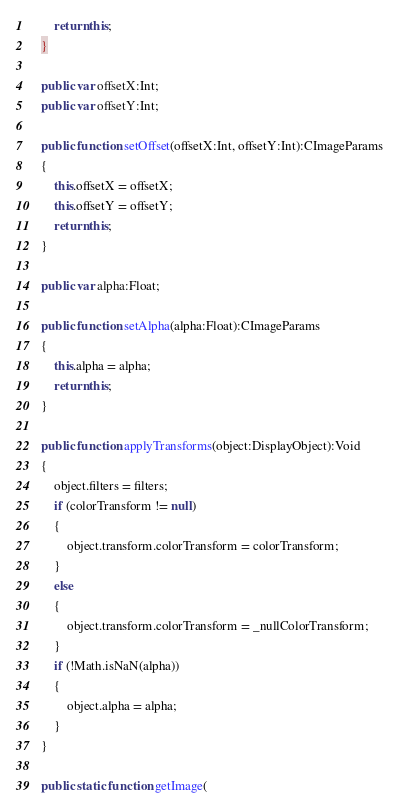<code> <loc_0><loc_0><loc_500><loc_500><_Haxe_>		return this;
	}
	
	public var offsetX:Int;
	public var offsetY:Int;
	
	public function setOffset(offsetX:Int, offsetY:Int):CImageParams
	{
		this.offsetX = offsetX;
		this.offsetY = offsetY;
		return this;
	}
	
	public var alpha:Float;
	
	public function setAlpha(alpha:Float):CImageParams
	{
		this.alpha = alpha;
		return this;
	}
	
	public function applyTransforms(object:DisplayObject):Void
	{
		object.filters = filters;
		if (colorTransform != null)
		{
			object.transform.colorTransform = colorTransform;
		}
		else
		{
			object.transform.colorTransform = _nullColorTransform;
		}
		if (!Math.isNaN(alpha))
		{
			object.alpha = alpha;
		}
	}
	
	public static function getImage(</code> 